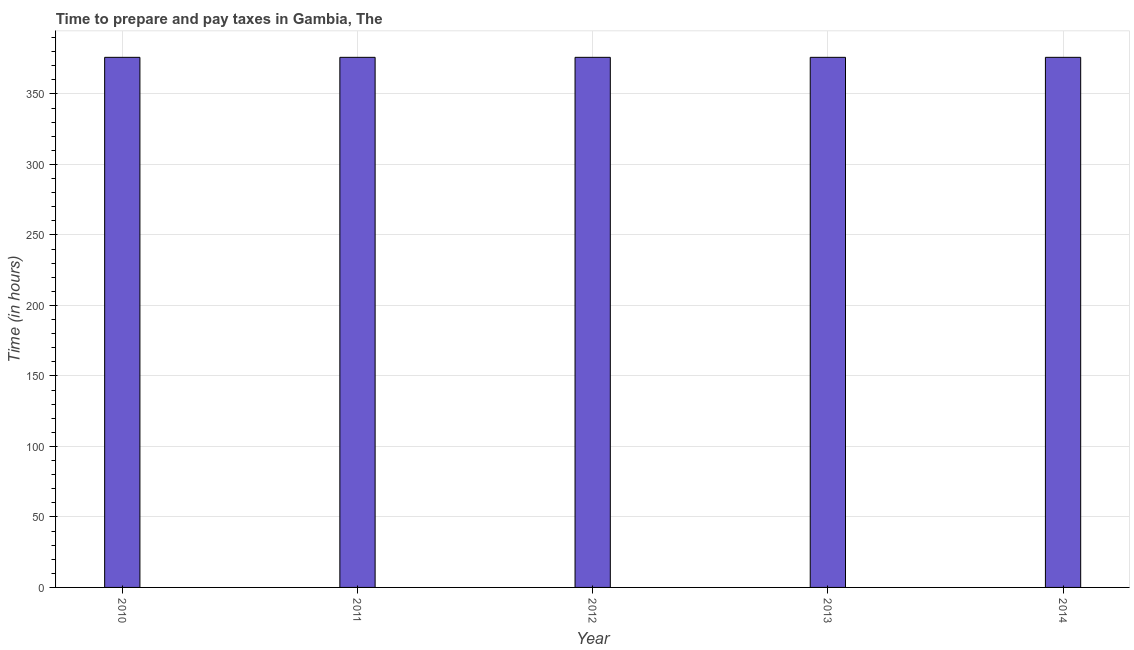Does the graph contain any zero values?
Offer a very short reply. No. Does the graph contain grids?
Give a very brief answer. Yes. What is the title of the graph?
Provide a succinct answer. Time to prepare and pay taxes in Gambia, The. What is the label or title of the X-axis?
Your answer should be compact. Year. What is the label or title of the Y-axis?
Your answer should be very brief. Time (in hours). What is the time to prepare and pay taxes in 2010?
Your answer should be compact. 376. Across all years, what is the maximum time to prepare and pay taxes?
Keep it short and to the point. 376. Across all years, what is the minimum time to prepare and pay taxes?
Offer a terse response. 376. In which year was the time to prepare and pay taxes maximum?
Provide a short and direct response. 2010. What is the sum of the time to prepare and pay taxes?
Offer a very short reply. 1880. What is the average time to prepare and pay taxes per year?
Your answer should be compact. 376. What is the median time to prepare and pay taxes?
Keep it short and to the point. 376. In how many years, is the time to prepare and pay taxes greater than 60 hours?
Ensure brevity in your answer.  5. Do a majority of the years between 2014 and 2013 (inclusive) have time to prepare and pay taxes greater than 210 hours?
Provide a short and direct response. No. What is the ratio of the time to prepare and pay taxes in 2013 to that in 2014?
Keep it short and to the point. 1. What is the difference between the highest and the second highest time to prepare and pay taxes?
Keep it short and to the point. 0. What is the difference between the highest and the lowest time to prepare and pay taxes?
Provide a succinct answer. 0. In how many years, is the time to prepare and pay taxes greater than the average time to prepare and pay taxes taken over all years?
Ensure brevity in your answer.  0. How many bars are there?
Give a very brief answer. 5. How many years are there in the graph?
Your response must be concise. 5. What is the difference between two consecutive major ticks on the Y-axis?
Make the answer very short. 50. What is the Time (in hours) of 2010?
Your answer should be very brief. 376. What is the Time (in hours) of 2011?
Ensure brevity in your answer.  376. What is the Time (in hours) of 2012?
Your response must be concise. 376. What is the Time (in hours) in 2013?
Offer a very short reply. 376. What is the Time (in hours) in 2014?
Give a very brief answer. 376. What is the difference between the Time (in hours) in 2010 and 2012?
Offer a very short reply. 0. What is the difference between the Time (in hours) in 2010 and 2013?
Give a very brief answer. 0. What is the difference between the Time (in hours) in 2011 and 2012?
Your answer should be compact. 0. What is the difference between the Time (in hours) in 2011 and 2014?
Your answer should be compact. 0. What is the difference between the Time (in hours) in 2012 and 2013?
Make the answer very short. 0. What is the ratio of the Time (in hours) in 2011 to that in 2013?
Your response must be concise. 1. What is the ratio of the Time (in hours) in 2011 to that in 2014?
Offer a very short reply. 1. What is the ratio of the Time (in hours) in 2013 to that in 2014?
Your response must be concise. 1. 